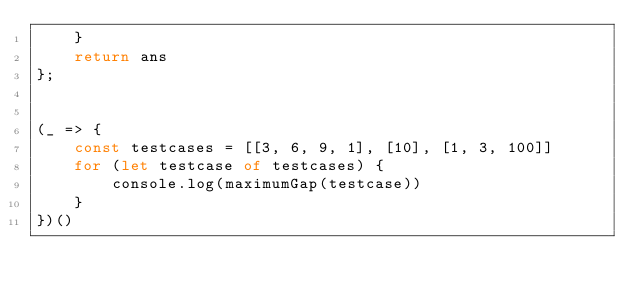<code> <loc_0><loc_0><loc_500><loc_500><_TypeScript_>    }
    return ans
};


(_ => {
    const testcases = [[3, 6, 9, 1], [10], [1, 3, 100]]
    for (let testcase of testcases) {
        console.log(maximumGap(testcase))
    }
})()</code> 